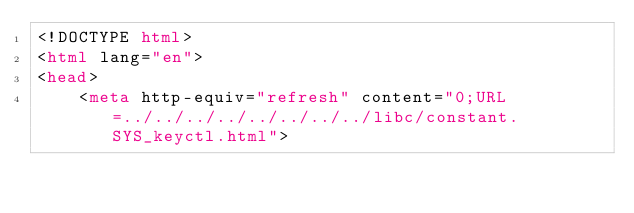<code> <loc_0><loc_0><loc_500><loc_500><_HTML_><!DOCTYPE html>
<html lang="en">
<head>
    <meta http-equiv="refresh" content="0;URL=../../../../../../../../libc/constant.SYS_keyctl.html"></code> 